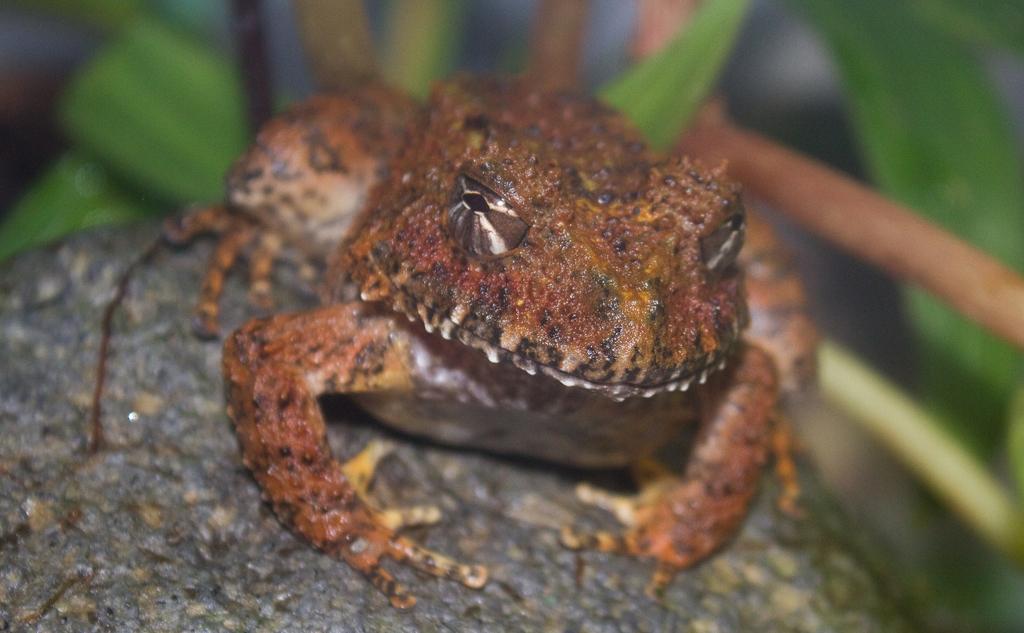In one or two sentences, can you explain what this image depicts? In this image I can see a frog in brown color, behind this there are leaves. 